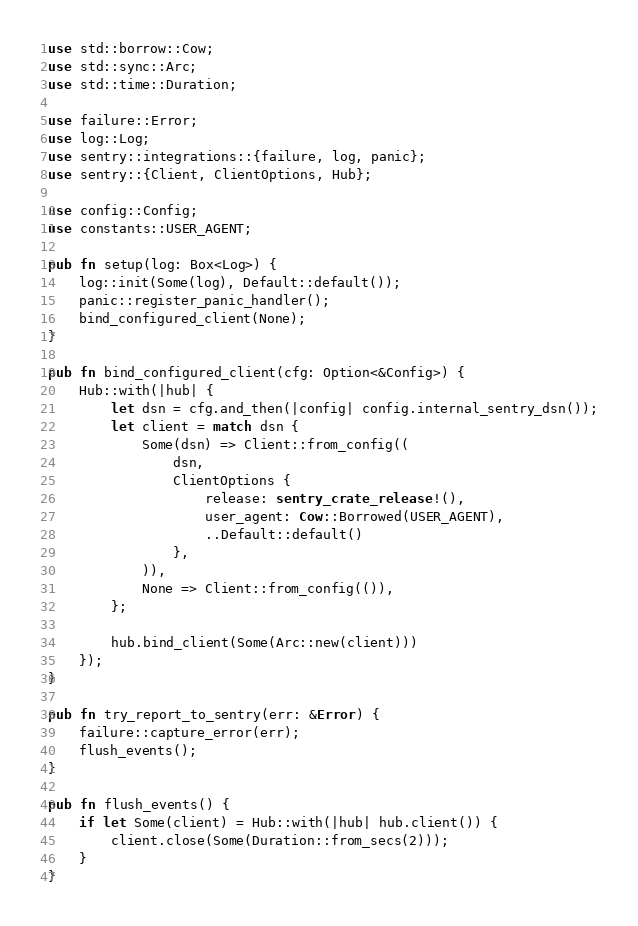Convert code to text. <code><loc_0><loc_0><loc_500><loc_500><_Rust_>use std::borrow::Cow;
use std::sync::Arc;
use std::time::Duration;

use failure::Error;
use log::Log;
use sentry::integrations::{failure, log, panic};
use sentry::{Client, ClientOptions, Hub};

use config::Config;
use constants::USER_AGENT;

pub fn setup(log: Box<Log>) {
    log::init(Some(log), Default::default());
    panic::register_panic_handler();
    bind_configured_client(None);
}

pub fn bind_configured_client(cfg: Option<&Config>) {
    Hub::with(|hub| {
        let dsn = cfg.and_then(|config| config.internal_sentry_dsn());
        let client = match dsn {
            Some(dsn) => Client::from_config((
                dsn,
                ClientOptions {
                    release: sentry_crate_release!(),
                    user_agent: Cow::Borrowed(USER_AGENT),
                    ..Default::default()
                },
            )),
            None => Client::from_config(()),
        };

        hub.bind_client(Some(Arc::new(client)))
    });
}

pub fn try_report_to_sentry(err: &Error) {
    failure::capture_error(err);
    flush_events();
}

pub fn flush_events() {
    if let Some(client) = Hub::with(|hub| hub.client()) {
        client.close(Some(Duration::from_secs(2)));
    }
}
</code> 